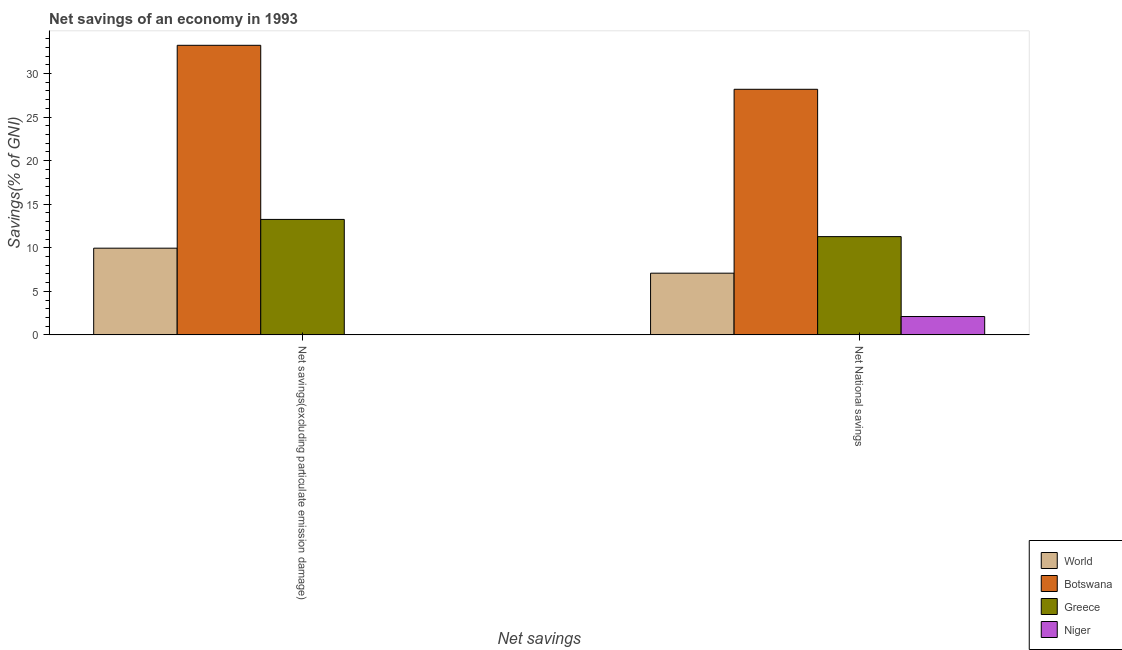How many groups of bars are there?
Your response must be concise. 2. Are the number of bars per tick equal to the number of legend labels?
Give a very brief answer. No. Are the number of bars on each tick of the X-axis equal?
Offer a very short reply. No. How many bars are there on the 2nd tick from the right?
Make the answer very short. 3. What is the label of the 1st group of bars from the left?
Make the answer very short. Net savings(excluding particulate emission damage). What is the net national savings in Niger?
Your response must be concise. 2.11. Across all countries, what is the maximum net national savings?
Keep it short and to the point. 28.19. Across all countries, what is the minimum net savings(excluding particulate emission damage)?
Make the answer very short. 0. In which country was the net savings(excluding particulate emission damage) maximum?
Your answer should be compact. Botswana. What is the total net national savings in the graph?
Give a very brief answer. 48.66. What is the difference between the net savings(excluding particulate emission damage) in Botswana and that in World?
Provide a short and direct response. 23.29. What is the difference between the net national savings in Niger and the net savings(excluding particulate emission damage) in Botswana?
Your response must be concise. -31.13. What is the average net national savings per country?
Your answer should be very brief. 12.17. What is the difference between the net savings(excluding particulate emission damage) and net national savings in World?
Provide a short and direct response. 2.87. In how many countries, is the net savings(excluding particulate emission damage) greater than 27 %?
Provide a short and direct response. 1. What is the ratio of the net savings(excluding particulate emission damage) in Botswana to that in World?
Give a very brief answer. 3.34. In how many countries, is the net national savings greater than the average net national savings taken over all countries?
Your answer should be very brief. 1. Are all the bars in the graph horizontal?
Your answer should be very brief. No. Does the graph contain grids?
Provide a succinct answer. No. Where does the legend appear in the graph?
Your answer should be very brief. Bottom right. What is the title of the graph?
Your response must be concise. Net savings of an economy in 1993. What is the label or title of the X-axis?
Give a very brief answer. Net savings. What is the label or title of the Y-axis?
Offer a very short reply. Savings(% of GNI). What is the Savings(% of GNI) in World in Net savings(excluding particulate emission damage)?
Your answer should be very brief. 9.95. What is the Savings(% of GNI) of Botswana in Net savings(excluding particulate emission damage)?
Provide a short and direct response. 33.24. What is the Savings(% of GNI) in Greece in Net savings(excluding particulate emission damage)?
Your response must be concise. 13.26. What is the Savings(% of GNI) of World in Net National savings?
Your answer should be very brief. 7.08. What is the Savings(% of GNI) in Botswana in Net National savings?
Offer a very short reply. 28.19. What is the Savings(% of GNI) of Greece in Net National savings?
Provide a succinct answer. 11.28. What is the Savings(% of GNI) of Niger in Net National savings?
Offer a terse response. 2.11. Across all Net savings, what is the maximum Savings(% of GNI) of World?
Keep it short and to the point. 9.95. Across all Net savings, what is the maximum Savings(% of GNI) of Botswana?
Offer a terse response. 33.24. Across all Net savings, what is the maximum Savings(% of GNI) in Greece?
Keep it short and to the point. 13.26. Across all Net savings, what is the maximum Savings(% of GNI) of Niger?
Offer a terse response. 2.11. Across all Net savings, what is the minimum Savings(% of GNI) of World?
Offer a very short reply. 7.08. Across all Net savings, what is the minimum Savings(% of GNI) in Botswana?
Give a very brief answer. 28.19. Across all Net savings, what is the minimum Savings(% of GNI) of Greece?
Give a very brief answer. 11.28. Across all Net savings, what is the minimum Savings(% of GNI) of Niger?
Offer a terse response. 0. What is the total Savings(% of GNI) in World in the graph?
Offer a very short reply. 17.04. What is the total Savings(% of GNI) of Botswana in the graph?
Your answer should be very brief. 61.43. What is the total Savings(% of GNI) of Greece in the graph?
Your answer should be compact. 24.54. What is the total Savings(% of GNI) in Niger in the graph?
Your response must be concise. 2.11. What is the difference between the Savings(% of GNI) of World in Net savings(excluding particulate emission damage) and that in Net National savings?
Keep it short and to the point. 2.87. What is the difference between the Savings(% of GNI) in Botswana in Net savings(excluding particulate emission damage) and that in Net National savings?
Your answer should be very brief. 5.05. What is the difference between the Savings(% of GNI) in Greece in Net savings(excluding particulate emission damage) and that in Net National savings?
Your answer should be very brief. 1.98. What is the difference between the Savings(% of GNI) of World in Net savings(excluding particulate emission damage) and the Savings(% of GNI) of Botswana in Net National savings?
Make the answer very short. -18.24. What is the difference between the Savings(% of GNI) in World in Net savings(excluding particulate emission damage) and the Savings(% of GNI) in Greece in Net National savings?
Your answer should be compact. -1.33. What is the difference between the Savings(% of GNI) of World in Net savings(excluding particulate emission damage) and the Savings(% of GNI) of Niger in Net National savings?
Your response must be concise. 7.85. What is the difference between the Savings(% of GNI) in Botswana in Net savings(excluding particulate emission damage) and the Savings(% of GNI) in Greece in Net National savings?
Provide a succinct answer. 21.96. What is the difference between the Savings(% of GNI) of Botswana in Net savings(excluding particulate emission damage) and the Savings(% of GNI) of Niger in Net National savings?
Make the answer very short. 31.13. What is the difference between the Savings(% of GNI) in Greece in Net savings(excluding particulate emission damage) and the Savings(% of GNI) in Niger in Net National savings?
Offer a very short reply. 11.15. What is the average Savings(% of GNI) of World per Net savings?
Ensure brevity in your answer.  8.52. What is the average Savings(% of GNI) of Botswana per Net savings?
Provide a short and direct response. 30.72. What is the average Savings(% of GNI) of Greece per Net savings?
Offer a terse response. 12.27. What is the average Savings(% of GNI) of Niger per Net savings?
Make the answer very short. 1.05. What is the difference between the Savings(% of GNI) of World and Savings(% of GNI) of Botswana in Net savings(excluding particulate emission damage)?
Provide a short and direct response. -23.29. What is the difference between the Savings(% of GNI) of World and Savings(% of GNI) of Greece in Net savings(excluding particulate emission damage)?
Provide a short and direct response. -3.3. What is the difference between the Savings(% of GNI) in Botswana and Savings(% of GNI) in Greece in Net savings(excluding particulate emission damage)?
Ensure brevity in your answer.  19.99. What is the difference between the Savings(% of GNI) of World and Savings(% of GNI) of Botswana in Net National savings?
Your answer should be very brief. -21.11. What is the difference between the Savings(% of GNI) of World and Savings(% of GNI) of Greece in Net National savings?
Give a very brief answer. -4.2. What is the difference between the Savings(% of GNI) of World and Savings(% of GNI) of Niger in Net National savings?
Your answer should be compact. 4.98. What is the difference between the Savings(% of GNI) of Botswana and Savings(% of GNI) of Greece in Net National savings?
Your answer should be very brief. 16.91. What is the difference between the Savings(% of GNI) of Botswana and Savings(% of GNI) of Niger in Net National savings?
Make the answer very short. 26.08. What is the difference between the Savings(% of GNI) of Greece and Savings(% of GNI) of Niger in Net National savings?
Your answer should be very brief. 9.17. What is the ratio of the Savings(% of GNI) in World in Net savings(excluding particulate emission damage) to that in Net National savings?
Your answer should be compact. 1.41. What is the ratio of the Savings(% of GNI) in Botswana in Net savings(excluding particulate emission damage) to that in Net National savings?
Give a very brief answer. 1.18. What is the ratio of the Savings(% of GNI) in Greece in Net savings(excluding particulate emission damage) to that in Net National savings?
Give a very brief answer. 1.18. What is the difference between the highest and the second highest Savings(% of GNI) of World?
Your answer should be compact. 2.87. What is the difference between the highest and the second highest Savings(% of GNI) in Botswana?
Your answer should be compact. 5.05. What is the difference between the highest and the second highest Savings(% of GNI) of Greece?
Make the answer very short. 1.98. What is the difference between the highest and the lowest Savings(% of GNI) of World?
Your answer should be very brief. 2.87. What is the difference between the highest and the lowest Savings(% of GNI) in Botswana?
Your answer should be very brief. 5.05. What is the difference between the highest and the lowest Savings(% of GNI) in Greece?
Make the answer very short. 1.98. What is the difference between the highest and the lowest Savings(% of GNI) in Niger?
Provide a short and direct response. 2.11. 